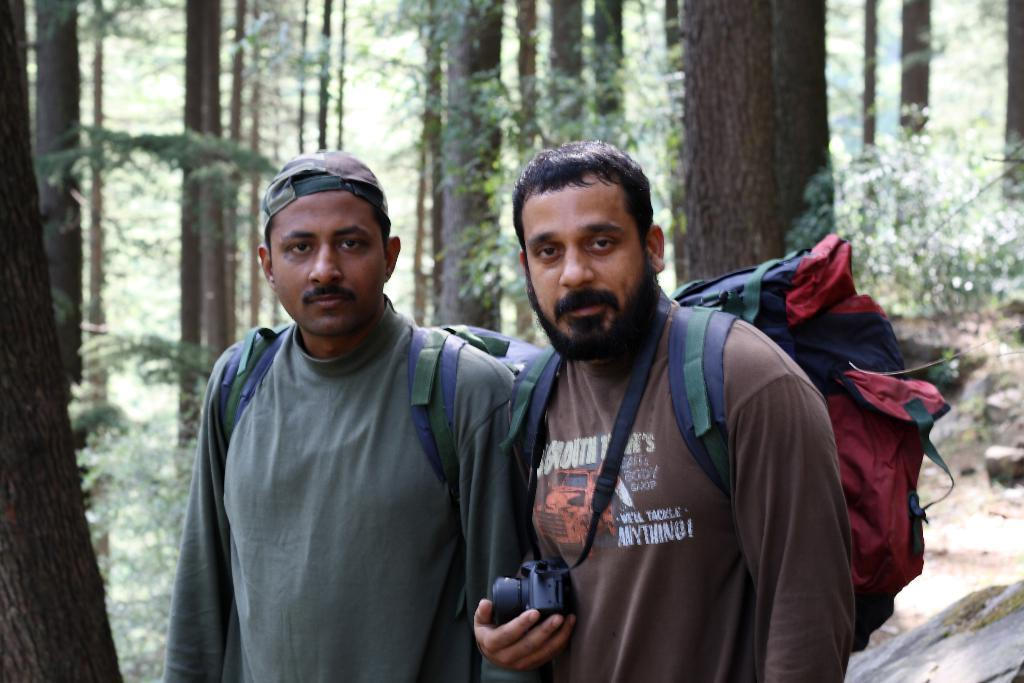How many people are in the image? There are two men standing in the image. What are the men carrying? The men are carrying bags. What else can be seen in the man's hand? One man is holding a camera in his hand. What can be seen in the background of the image? There are trees visible in the background of the image. What type of popcorn is being served in the image? There is no popcorn present in the image. Can you tell me where the map is located in the image? There is no map present in the image. 